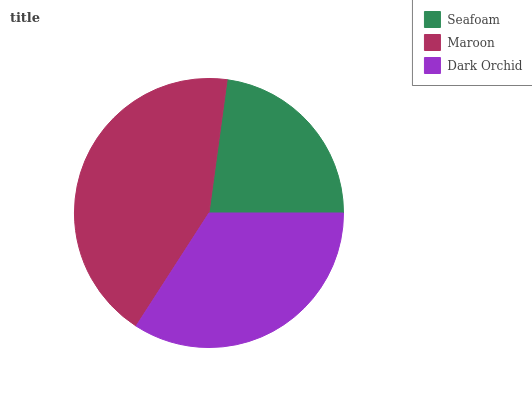Is Seafoam the minimum?
Answer yes or no. Yes. Is Maroon the maximum?
Answer yes or no. Yes. Is Dark Orchid the minimum?
Answer yes or no. No. Is Dark Orchid the maximum?
Answer yes or no. No. Is Maroon greater than Dark Orchid?
Answer yes or no. Yes. Is Dark Orchid less than Maroon?
Answer yes or no. Yes. Is Dark Orchid greater than Maroon?
Answer yes or no. No. Is Maroon less than Dark Orchid?
Answer yes or no. No. Is Dark Orchid the high median?
Answer yes or no. Yes. Is Dark Orchid the low median?
Answer yes or no. Yes. Is Seafoam the high median?
Answer yes or no. No. Is Maroon the low median?
Answer yes or no. No. 